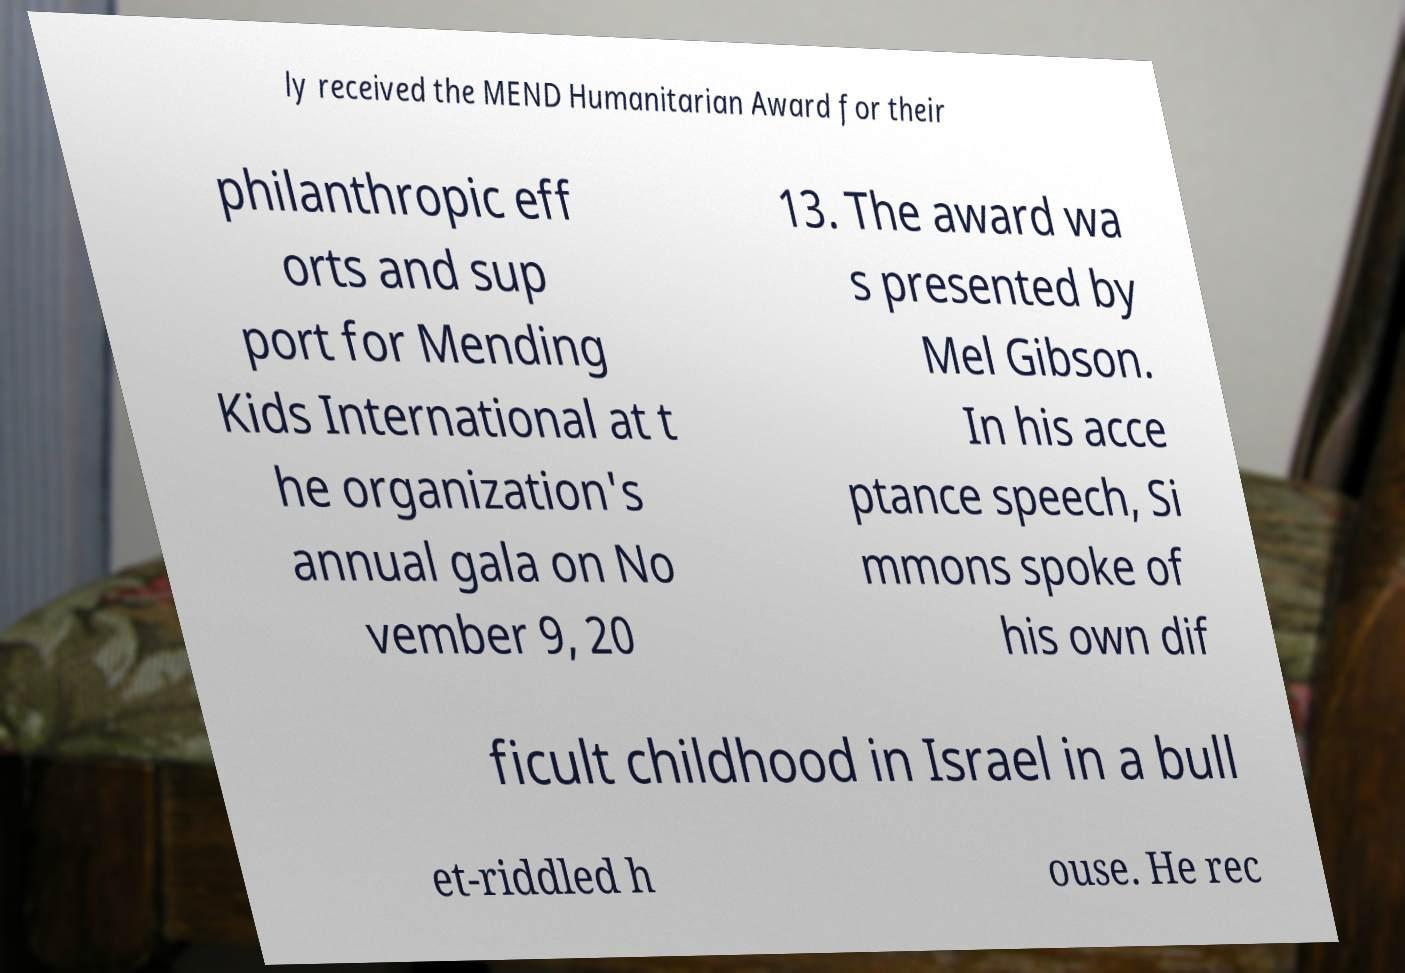There's text embedded in this image that I need extracted. Can you transcribe it verbatim? ly received the MEND Humanitarian Award for their philanthropic eff orts and sup port for Mending Kids International at t he organization's annual gala on No vember 9, 20 13. The award wa s presented by Mel Gibson. In his acce ptance speech, Si mmons spoke of his own dif ficult childhood in Israel in a bull et-riddled h ouse. He rec 